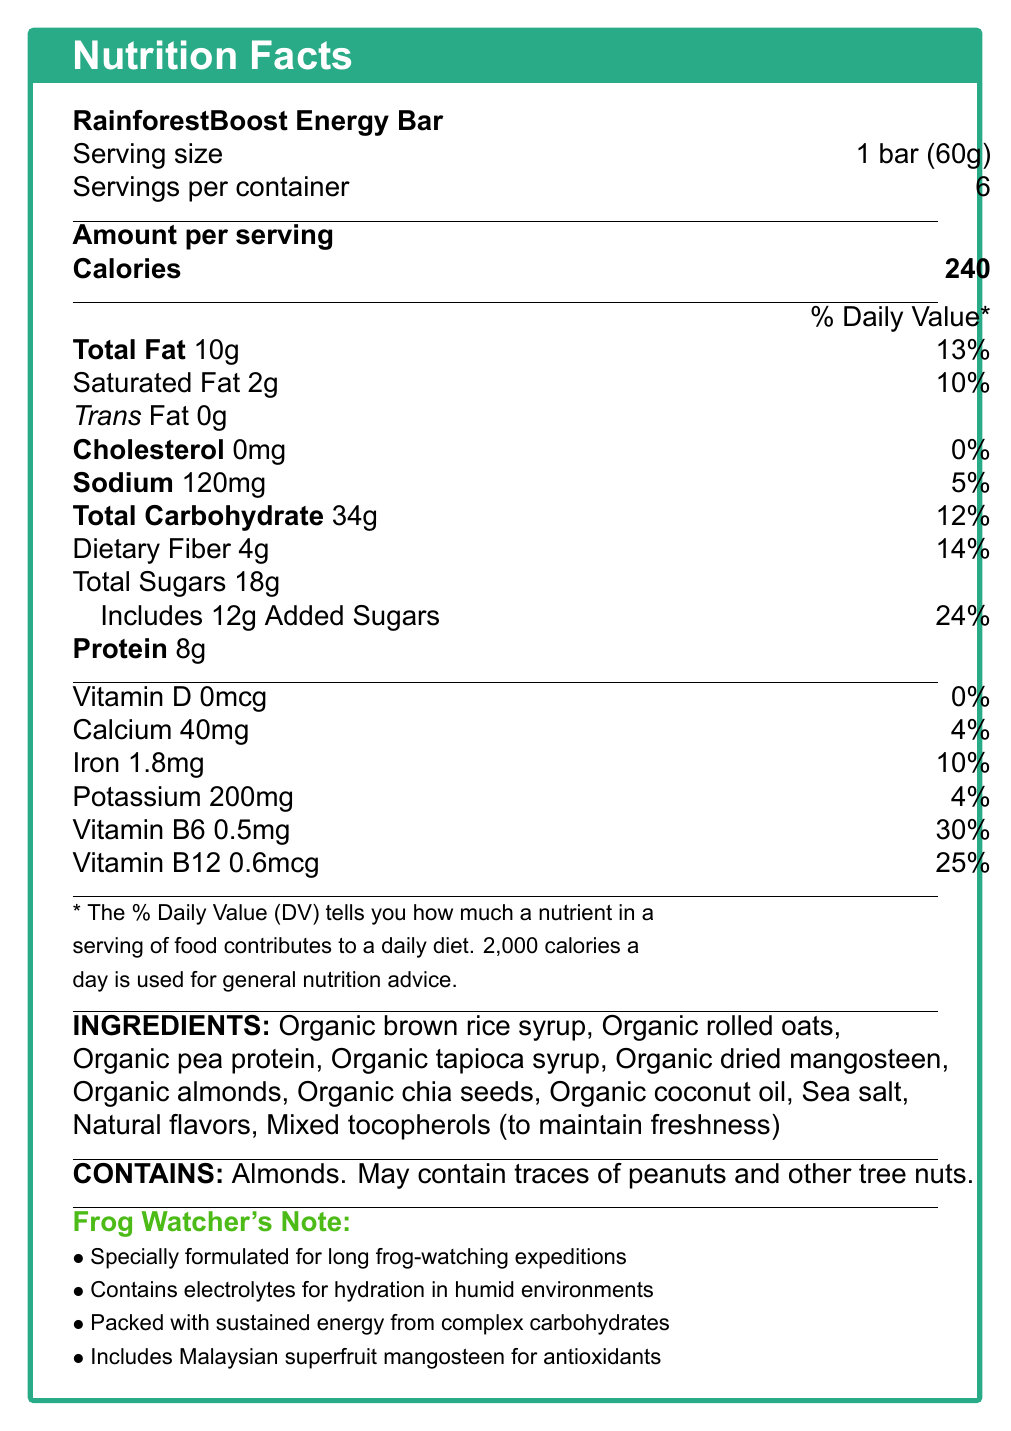what is the serving size of the RainforestBoost Energy Bar? The document states that the serving size for the RainforestBoost Energy Bar is "1 bar (60g)".
Answer: 1 bar (60g) how many servings are there per container? The document indicates that there are 6 servings per container of RainforestBoost Energy Bar.
Answer: 6 how many calories are in one serving of the RainforestBoost Energy Bar? The document specifies that each serving of the RainforestBoost Energy Bar contains 240 calories.
Answer: 240 what is the total amount of fat in one serving of the RainforestBoost Energy Bar? The total fat amount per serving in the RainforestBoost Energy Bar is 10g.
Answer: 10g what is the percentage of daily value for vitamin B6 in the RainforestBoost Energy Bar? The document shows that the percentage of daily value for vitamin B6 in one serving is 30%.
Answer: 30% which nutrient has the highest daily value percentage per serving? 
A. Vitamin B12 
B. Potassium 
C. Total Fat 
D. Vitamin B6 Among the listed options, Vitamin B6 has the highest daily value percentage per serving at 30%.
Answer: D. Vitamin B6 how much dietary fiber is in one serving of the RainforestBoost Energy Bar? 
1. 3g 
2. 4g 
3. 5g 
4. 6g The document indicates that there are 4g of dietary fiber in one serving of the RainforestBoost Energy Bar.
Answer: 2. 4g does the RainforestBoost Energy Bar contain any cholesterol? The document shows that the amount of cholesterol in the RainforestBoost Energy Bar is 0mg, and the daily value percentage is 0%.
Answer: No is the RainforestBoost Energy Bar suitable for people with peanut allergies? The document states that the product contains almonds and may contain traces of peanuts and other tree nuts, making it unsuitable for people with peanut allergies.
Answer: No summarize the main features and nutrition details of the RainforestBoost Energy Bar. The summary encompasses the key features, intended usage, nutritional benefits, and allergen information of the RainforestBoost Energy Bar, covering all relevant aspects mentioned in the document.
Answer: The RainforestBoost Energy Bar is designed for long frog-watching expeditions in Malaysian rainforests, containing electrolytes for hydration and sustained energy from complex carbohydrates. It includes the superfruit mangosteen for antioxidant benefits. Each bar (60g serving size) provides 240 calories, 10g total fat, 34g total carbohydrates, 4g dietary fiber, 18g total sugars (with 12g added sugars), 8g protein, and various vitamins and minerals. The main ingredients are organic and it contains almonds, potentially other tree nuts. what percentage of daily value for sodium does one serving of the RainforestBoost Energy Bar provide? The document indicates that one serving of the energy bar provides 5% of the daily value for sodium.
Answer: 5% what is the main antioxidant component included in the RainforestBoost Energy Bar? The document highlights that the RainforestBoost Energy Bar includes local Malaysian superfruit mangosteen for antioxidant benefits.
Answer: Mangosteen how many grams of protein are in each serving of the RainforestBoost Energy Bar? The document states that each serving of the RainforestBoost Energy Bar contains 8g of protein.
Answer: 8g does the RainforestBoost Energy Bar contribute to daily iron intake? If so, by what percentage? The document indicates that one serving of the RainforestBoost Energy Bar provides 10% of the daily value for iron.
Answer: Yes, 10% how many milligrams of potassium are in one serving of the RainforestBoost Energy Bar? According to the document, one serving contains 200mg of potassium.
Answer: 200mg what are the first three ingredients listed for the RainforestBoost Energy Bar? The first three ingredients listed are Organic brown rice syrup, Organic rolled oats, and Organic pea protein.
Answer: Organic brown rice syrup, Organic rolled oats, Organic pea protein how effective is the RainforestBoost Energy Bar in maintaining hydration in humid environments according to the document? The effectiveness of the RainforestBoost Energy Bar in maintaining hydration in humid environments cannot be determined solely from the information provided in the document.
Answer: Cannot be determined 